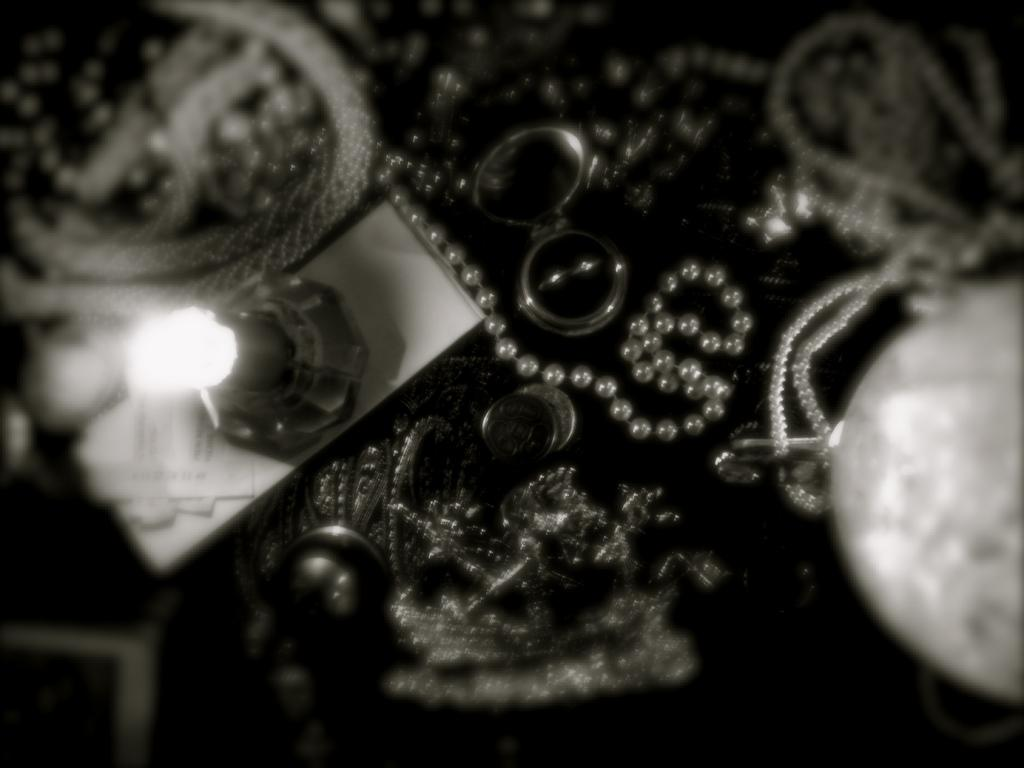What is the color scheme of the image? The image is black and white. What type of object can be seen in the image? There is a lamp in the image. What material is present in the image? There is paper in the image. What type of accessory is in the image? There are chains in the image. What type of jewelry is in the image? There is a ring in the image. What type of container is in the image? There is a box in the image. Can you describe any other objects in the image? There are other unspecified objects in the image. How many ducks are balancing on the ring in the image? There are no ducks present in the image, and therefore no ducks can be seen balancing on the ring. 